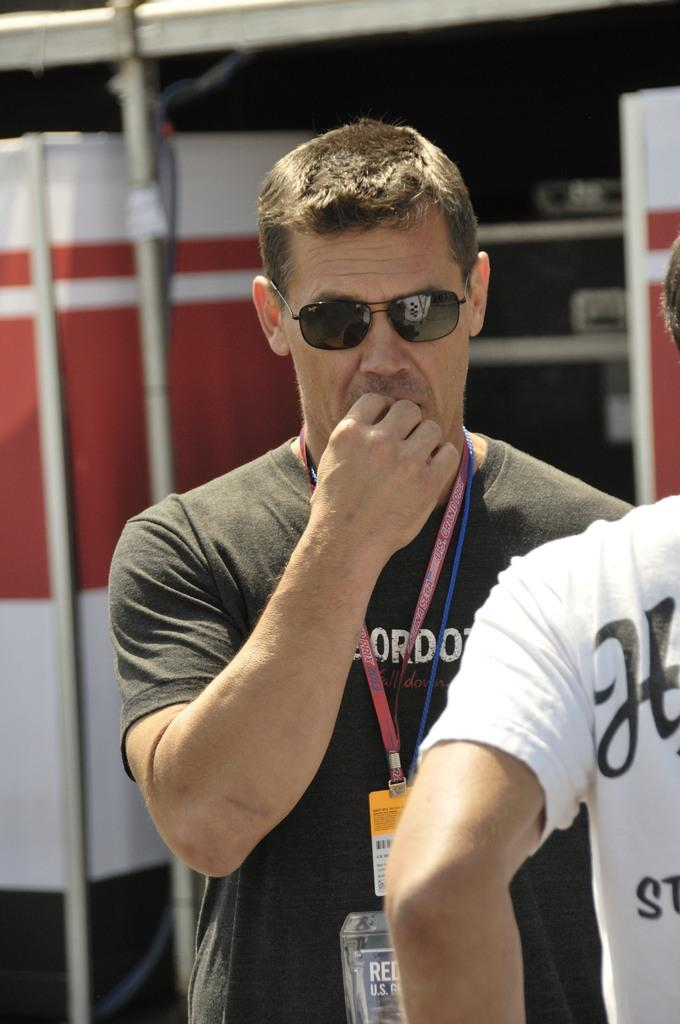<image>
Share a concise interpretation of the image provided. Man is standing next to a person wearing a white shirt with a letter H on the back. 